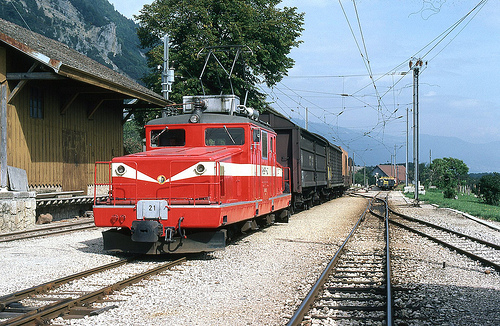Does the train look blue? No, the train is red and not blue, contrasting sharply with the surrounding natural elements. 